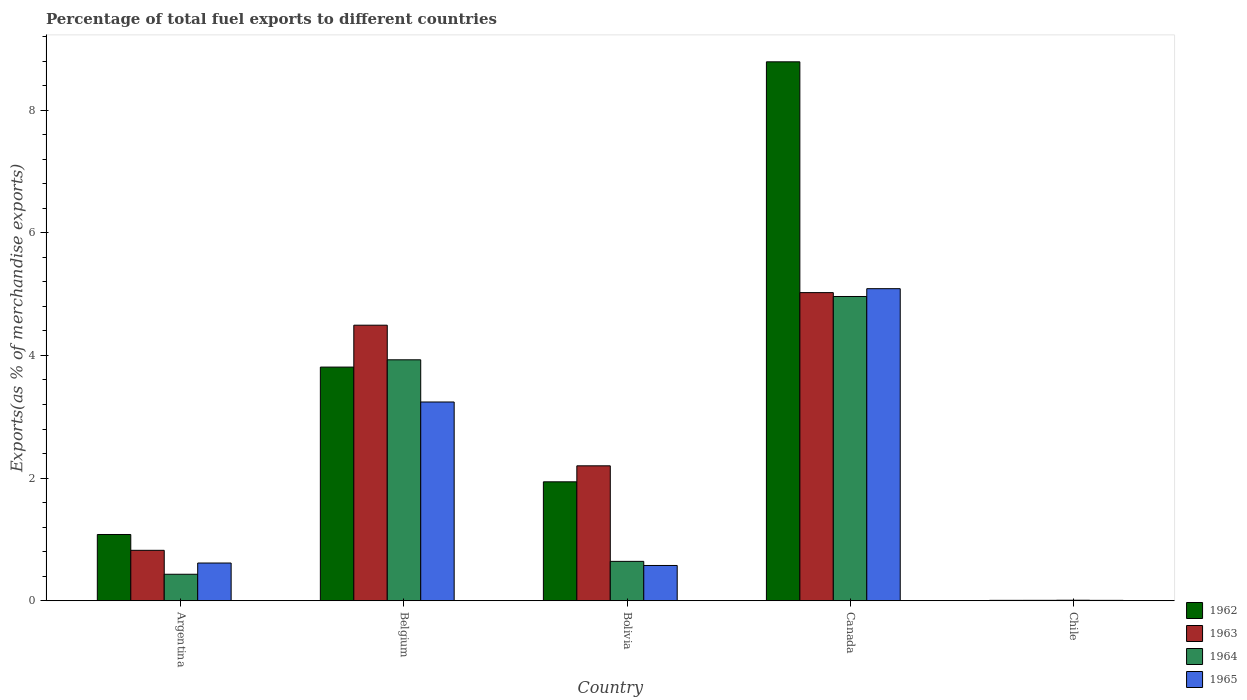How many groups of bars are there?
Provide a short and direct response. 5. Are the number of bars on each tick of the X-axis equal?
Keep it short and to the point. Yes. How many bars are there on the 2nd tick from the left?
Make the answer very short. 4. What is the label of the 2nd group of bars from the left?
Offer a very short reply. Belgium. What is the percentage of exports to different countries in 1965 in Argentina?
Provide a succinct answer. 0.62. Across all countries, what is the maximum percentage of exports to different countries in 1964?
Offer a very short reply. 4.96. Across all countries, what is the minimum percentage of exports to different countries in 1963?
Your response must be concise. 0.01. In which country was the percentage of exports to different countries in 1965 minimum?
Your answer should be very brief. Chile. What is the total percentage of exports to different countries in 1965 in the graph?
Provide a short and direct response. 9.53. What is the difference between the percentage of exports to different countries in 1965 in Bolivia and that in Chile?
Offer a terse response. 0.57. What is the difference between the percentage of exports to different countries in 1964 in Bolivia and the percentage of exports to different countries in 1965 in Chile?
Your answer should be very brief. 0.64. What is the average percentage of exports to different countries in 1964 per country?
Make the answer very short. 1.99. What is the difference between the percentage of exports to different countries of/in 1964 and percentage of exports to different countries of/in 1962 in Chile?
Your answer should be very brief. 0. What is the ratio of the percentage of exports to different countries in 1965 in Argentina to that in Belgium?
Provide a succinct answer. 0.19. Is the difference between the percentage of exports to different countries in 1964 in Belgium and Bolivia greater than the difference between the percentage of exports to different countries in 1962 in Belgium and Bolivia?
Offer a terse response. Yes. What is the difference between the highest and the second highest percentage of exports to different countries in 1965?
Offer a terse response. -2.63. What is the difference between the highest and the lowest percentage of exports to different countries in 1964?
Provide a succinct answer. 4.95. In how many countries, is the percentage of exports to different countries in 1963 greater than the average percentage of exports to different countries in 1963 taken over all countries?
Your response must be concise. 2. What does the 1st bar from the left in Belgium represents?
Provide a succinct answer. 1962. Is it the case that in every country, the sum of the percentage of exports to different countries in 1962 and percentage of exports to different countries in 1963 is greater than the percentage of exports to different countries in 1965?
Offer a terse response. Yes. What is the difference between two consecutive major ticks on the Y-axis?
Keep it short and to the point. 2. Does the graph contain any zero values?
Offer a terse response. No. Does the graph contain grids?
Your response must be concise. No. How are the legend labels stacked?
Offer a terse response. Vertical. What is the title of the graph?
Your answer should be compact. Percentage of total fuel exports to different countries. Does "1966" appear as one of the legend labels in the graph?
Make the answer very short. No. What is the label or title of the Y-axis?
Make the answer very short. Exports(as % of merchandise exports). What is the Exports(as % of merchandise exports) in 1962 in Argentina?
Ensure brevity in your answer.  1.08. What is the Exports(as % of merchandise exports) in 1963 in Argentina?
Your response must be concise. 0.82. What is the Exports(as % of merchandise exports) in 1964 in Argentina?
Provide a succinct answer. 0.43. What is the Exports(as % of merchandise exports) in 1965 in Argentina?
Give a very brief answer. 0.62. What is the Exports(as % of merchandise exports) of 1962 in Belgium?
Ensure brevity in your answer.  3.81. What is the Exports(as % of merchandise exports) of 1963 in Belgium?
Offer a terse response. 4.49. What is the Exports(as % of merchandise exports) in 1964 in Belgium?
Give a very brief answer. 3.93. What is the Exports(as % of merchandise exports) in 1965 in Belgium?
Offer a terse response. 3.24. What is the Exports(as % of merchandise exports) of 1962 in Bolivia?
Keep it short and to the point. 1.94. What is the Exports(as % of merchandise exports) in 1963 in Bolivia?
Ensure brevity in your answer.  2.2. What is the Exports(as % of merchandise exports) in 1964 in Bolivia?
Your response must be concise. 0.64. What is the Exports(as % of merchandise exports) of 1965 in Bolivia?
Ensure brevity in your answer.  0.58. What is the Exports(as % of merchandise exports) of 1962 in Canada?
Keep it short and to the point. 8.79. What is the Exports(as % of merchandise exports) in 1963 in Canada?
Give a very brief answer. 5.02. What is the Exports(as % of merchandise exports) of 1964 in Canada?
Make the answer very short. 4.96. What is the Exports(as % of merchandise exports) of 1965 in Canada?
Offer a very short reply. 5.09. What is the Exports(as % of merchandise exports) in 1962 in Chile?
Keep it short and to the point. 0.01. What is the Exports(as % of merchandise exports) of 1963 in Chile?
Your answer should be compact. 0.01. What is the Exports(as % of merchandise exports) in 1964 in Chile?
Make the answer very short. 0.01. What is the Exports(as % of merchandise exports) of 1965 in Chile?
Keep it short and to the point. 0.01. Across all countries, what is the maximum Exports(as % of merchandise exports) in 1962?
Your answer should be compact. 8.79. Across all countries, what is the maximum Exports(as % of merchandise exports) of 1963?
Your answer should be very brief. 5.02. Across all countries, what is the maximum Exports(as % of merchandise exports) of 1964?
Offer a terse response. 4.96. Across all countries, what is the maximum Exports(as % of merchandise exports) of 1965?
Provide a short and direct response. 5.09. Across all countries, what is the minimum Exports(as % of merchandise exports) in 1962?
Keep it short and to the point. 0.01. Across all countries, what is the minimum Exports(as % of merchandise exports) of 1963?
Offer a terse response. 0.01. Across all countries, what is the minimum Exports(as % of merchandise exports) of 1964?
Your answer should be compact. 0.01. Across all countries, what is the minimum Exports(as % of merchandise exports) of 1965?
Keep it short and to the point. 0.01. What is the total Exports(as % of merchandise exports) in 1962 in the graph?
Your response must be concise. 15.63. What is the total Exports(as % of merchandise exports) in 1963 in the graph?
Provide a short and direct response. 12.55. What is the total Exports(as % of merchandise exports) of 1964 in the graph?
Your answer should be very brief. 9.97. What is the total Exports(as % of merchandise exports) of 1965 in the graph?
Your answer should be compact. 9.53. What is the difference between the Exports(as % of merchandise exports) in 1962 in Argentina and that in Belgium?
Your response must be concise. -2.73. What is the difference between the Exports(as % of merchandise exports) of 1963 in Argentina and that in Belgium?
Your answer should be very brief. -3.67. What is the difference between the Exports(as % of merchandise exports) in 1964 in Argentina and that in Belgium?
Provide a succinct answer. -3.5. What is the difference between the Exports(as % of merchandise exports) in 1965 in Argentina and that in Belgium?
Provide a succinct answer. -2.63. What is the difference between the Exports(as % of merchandise exports) of 1962 in Argentina and that in Bolivia?
Provide a succinct answer. -0.86. What is the difference between the Exports(as % of merchandise exports) of 1963 in Argentina and that in Bolivia?
Provide a succinct answer. -1.38. What is the difference between the Exports(as % of merchandise exports) of 1964 in Argentina and that in Bolivia?
Your answer should be compact. -0.21. What is the difference between the Exports(as % of merchandise exports) of 1965 in Argentina and that in Bolivia?
Your response must be concise. 0.04. What is the difference between the Exports(as % of merchandise exports) of 1962 in Argentina and that in Canada?
Provide a short and direct response. -7.71. What is the difference between the Exports(as % of merchandise exports) in 1963 in Argentina and that in Canada?
Your answer should be compact. -4.2. What is the difference between the Exports(as % of merchandise exports) in 1964 in Argentina and that in Canada?
Your answer should be very brief. -4.53. What is the difference between the Exports(as % of merchandise exports) in 1965 in Argentina and that in Canada?
Offer a very short reply. -4.47. What is the difference between the Exports(as % of merchandise exports) in 1962 in Argentina and that in Chile?
Keep it short and to the point. 1.07. What is the difference between the Exports(as % of merchandise exports) of 1963 in Argentina and that in Chile?
Keep it short and to the point. 0.82. What is the difference between the Exports(as % of merchandise exports) of 1964 in Argentina and that in Chile?
Provide a succinct answer. 0.42. What is the difference between the Exports(as % of merchandise exports) in 1965 in Argentina and that in Chile?
Offer a terse response. 0.61. What is the difference between the Exports(as % of merchandise exports) in 1962 in Belgium and that in Bolivia?
Make the answer very short. 1.87. What is the difference between the Exports(as % of merchandise exports) in 1963 in Belgium and that in Bolivia?
Your answer should be very brief. 2.29. What is the difference between the Exports(as % of merchandise exports) in 1964 in Belgium and that in Bolivia?
Keep it short and to the point. 3.29. What is the difference between the Exports(as % of merchandise exports) in 1965 in Belgium and that in Bolivia?
Make the answer very short. 2.67. What is the difference between the Exports(as % of merchandise exports) in 1962 in Belgium and that in Canada?
Keep it short and to the point. -4.98. What is the difference between the Exports(as % of merchandise exports) in 1963 in Belgium and that in Canada?
Ensure brevity in your answer.  -0.53. What is the difference between the Exports(as % of merchandise exports) in 1964 in Belgium and that in Canada?
Give a very brief answer. -1.03. What is the difference between the Exports(as % of merchandise exports) of 1965 in Belgium and that in Canada?
Ensure brevity in your answer.  -1.85. What is the difference between the Exports(as % of merchandise exports) of 1962 in Belgium and that in Chile?
Give a very brief answer. 3.8. What is the difference between the Exports(as % of merchandise exports) in 1963 in Belgium and that in Chile?
Offer a terse response. 4.49. What is the difference between the Exports(as % of merchandise exports) in 1964 in Belgium and that in Chile?
Your answer should be very brief. 3.92. What is the difference between the Exports(as % of merchandise exports) of 1965 in Belgium and that in Chile?
Your answer should be very brief. 3.23. What is the difference between the Exports(as % of merchandise exports) of 1962 in Bolivia and that in Canada?
Keep it short and to the point. -6.85. What is the difference between the Exports(as % of merchandise exports) in 1963 in Bolivia and that in Canada?
Offer a very short reply. -2.82. What is the difference between the Exports(as % of merchandise exports) of 1964 in Bolivia and that in Canada?
Your answer should be compact. -4.32. What is the difference between the Exports(as % of merchandise exports) in 1965 in Bolivia and that in Canada?
Your answer should be compact. -4.51. What is the difference between the Exports(as % of merchandise exports) in 1962 in Bolivia and that in Chile?
Keep it short and to the point. 1.93. What is the difference between the Exports(as % of merchandise exports) in 1963 in Bolivia and that in Chile?
Ensure brevity in your answer.  2.19. What is the difference between the Exports(as % of merchandise exports) of 1964 in Bolivia and that in Chile?
Give a very brief answer. 0.63. What is the difference between the Exports(as % of merchandise exports) in 1965 in Bolivia and that in Chile?
Your response must be concise. 0.57. What is the difference between the Exports(as % of merchandise exports) of 1962 in Canada and that in Chile?
Your response must be concise. 8.78. What is the difference between the Exports(as % of merchandise exports) in 1963 in Canada and that in Chile?
Provide a short and direct response. 5.02. What is the difference between the Exports(as % of merchandise exports) in 1964 in Canada and that in Chile?
Make the answer very short. 4.95. What is the difference between the Exports(as % of merchandise exports) in 1965 in Canada and that in Chile?
Your answer should be compact. 5.08. What is the difference between the Exports(as % of merchandise exports) in 1962 in Argentina and the Exports(as % of merchandise exports) in 1963 in Belgium?
Keep it short and to the point. -3.41. What is the difference between the Exports(as % of merchandise exports) of 1962 in Argentina and the Exports(as % of merchandise exports) of 1964 in Belgium?
Keep it short and to the point. -2.85. What is the difference between the Exports(as % of merchandise exports) of 1962 in Argentina and the Exports(as % of merchandise exports) of 1965 in Belgium?
Make the answer very short. -2.16. What is the difference between the Exports(as % of merchandise exports) of 1963 in Argentina and the Exports(as % of merchandise exports) of 1964 in Belgium?
Provide a succinct answer. -3.11. What is the difference between the Exports(as % of merchandise exports) of 1963 in Argentina and the Exports(as % of merchandise exports) of 1965 in Belgium?
Your response must be concise. -2.42. What is the difference between the Exports(as % of merchandise exports) of 1964 in Argentina and the Exports(as % of merchandise exports) of 1965 in Belgium?
Give a very brief answer. -2.81. What is the difference between the Exports(as % of merchandise exports) in 1962 in Argentina and the Exports(as % of merchandise exports) in 1963 in Bolivia?
Give a very brief answer. -1.12. What is the difference between the Exports(as % of merchandise exports) in 1962 in Argentina and the Exports(as % of merchandise exports) in 1964 in Bolivia?
Give a very brief answer. 0.44. What is the difference between the Exports(as % of merchandise exports) in 1962 in Argentina and the Exports(as % of merchandise exports) in 1965 in Bolivia?
Keep it short and to the point. 0.51. What is the difference between the Exports(as % of merchandise exports) in 1963 in Argentina and the Exports(as % of merchandise exports) in 1964 in Bolivia?
Provide a succinct answer. 0.18. What is the difference between the Exports(as % of merchandise exports) in 1963 in Argentina and the Exports(as % of merchandise exports) in 1965 in Bolivia?
Ensure brevity in your answer.  0.25. What is the difference between the Exports(as % of merchandise exports) in 1964 in Argentina and the Exports(as % of merchandise exports) in 1965 in Bolivia?
Give a very brief answer. -0.14. What is the difference between the Exports(as % of merchandise exports) of 1962 in Argentina and the Exports(as % of merchandise exports) of 1963 in Canada?
Provide a short and direct response. -3.94. What is the difference between the Exports(as % of merchandise exports) of 1962 in Argentina and the Exports(as % of merchandise exports) of 1964 in Canada?
Ensure brevity in your answer.  -3.88. What is the difference between the Exports(as % of merchandise exports) of 1962 in Argentina and the Exports(as % of merchandise exports) of 1965 in Canada?
Keep it short and to the point. -4.01. What is the difference between the Exports(as % of merchandise exports) in 1963 in Argentina and the Exports(as % of merchandise exports) in 1964 in Canada?
Ensure brevity in your answer.  -4.14. What is the difference between the Exports(as % of merchandise exports) in 1963 in Argentina and the Exports(as % of merchandise exports) in 1965 in Canada?
Your response must be concise. -4.27. What is the difference between the Exports(as % of merchandise exports) in 1964 in Argentina and the Exports(as % of merchandise exports) in 1965 in Canada?
Ensure brevity in your answer.  -4.66. What is the difference between the Exports(as % of merchandise exports) in 1962 in Argentina and the Exports(as % of merchandise exports) in 1963 in Chile?
Your answer should be compact. 1.07. What is the difference between the Exports(as % of merchandise exports) of 1962 in Argentina and the Exports(as % of merchandise exports) of 1964 in Chile?
Ensure brevity in your answer.  1.07. What is the difference between the Exports(as % of merchandise exports) of 1962 in Argentina and the Exports(as % of merchandise exports) of 1965 in Chile?
Offer a terse response. 1.07. What is the difference between the Exports(as % of merchandise exports) in 1963 in Argentina and the Exports(as % of merchandise exports) in 1964 in Chile?
Ensure brevity in your answer.  0.81. What is the difference between the Exports(as % of merchandise exports) in 1963 in Argentina and the Exports(as % of merchandise exports) in 1965 in Chile?
Your answer should be compact. 0.82. What is the difference between the Exports(as % of merchandise exports) of 1964 in Argentina and the Exports(as % of merchandise exports) of 1965 in Chile?
Offer a terse response. 0.43. What is the difference between the Exports(as % of merchandise exports) of 1962 in Belgium and the Exports(as % of merchandise exports) of 1963 in Bolivia?
Keep it short and to the point. 1.61. What is the difference between the Exports(as % of merchandise exports) in 1962 in Belgium and the Exports(as % of merchandise exports) in 1964 in Bolivia?
Provide a succinct answer. 3.17. What is the difference between the Exports(as % of merchandise exports) in 1962 in Belgium and the Exports(as % of merchandise exports) in 1965 in Bolivia?
Your answer should be very brief. 3.23. What is the difference between the Exports(as % of merchandise exports) of 1963 in Belgium and the Exports(as % of merchandise exports) of 1964 in Bolivia?
Provide a succinct answer. 3.85. What is the difference between the Exports(as % of merchandise exports) in 1963 in Belgium and the Exports(as % of merchandise exports) in 1965 in Bolivia?
Give a very brief answer. 3.92. What is the difference between the Exports(as % of merchandise exports) of 1964 in Belgium and the Exports(as % of merchandise exports) of 1965 in Bolivia?
Provide a short and direct response. 3.35. What is the difference between the Exports(as % of merchandise exports) of 1962 in Belgium and the Exports(as % of merchandise exports) of 1963 in Canada?
Provide a succinct answer. -1.21. What is the difference between the Exports(as % of merchandise exports) in 1962 in Belgium and the Exports(as % of merchandise exports) in 1964 in Canada?
Provide a short and direct response. -1.15. What is the difference between the Exports(as % of merchandise exports) in 1962 in Belgium and the Exports(as % of merchandise exports) in 1965 in Canada?
Ensure brevity in your answer.  -1.28. What is the difference between the Exports(as % of merchandise exports) in 1963 in Belgium and the Exports(as % of merchandise exports) in 1964 in Canada?
Offer a terse response. -0.47. What is the difference between the Exports(as % of merchandise exports) in 1963 in Belgium and the Exports(as % of merchandise exports) in 1965 in Canada?
Give a very brief answer. -0.6. What is the difference between the Exports(as % of merchandise exports) of 1964 in Belgium and the Exports(as % of merchandise exports) of 1965 in Canada?
Ensure brevity in your answer.  -1.16. What is the difference between the Exports(as % of merchandise exports) in 1962 in Belgium and the Exports(as % of merchandise exports) in 1963 in Chile?
Offer a terse response. 3.8. What is the difference between the Exports(as % of merchandise exports) of 1962 in Belgium and the Exports(as % of merchandise exports) of 1964 in Chile?
Provide a short and direct response. 3.8. What is the difference between the Exports(as % of merchandise exports) in 1962 in Belgium and the Exports(as % of merchandise exports) in 1965 in Chile?
Offer a very short reply. 3.8. What is the difference between the Exports(as % of merchandise exports) in 1963 in Belgium and the Exports(as % of merchandise exports) in 1964 in Chile?
Your answer should be very brief. 4.48. What is the difference between the Exports(as % of merchandise exports) in 1963 in Belgium and the Exports(as % of merchandise exports) in 1965 in Chile?
Provide a succinct answer. 4.49. What is the difference between the Exports(as % of merchandise exports) in 1964 in Belgium and the Exports(as % of merchandise exports) in 1965 in Chile?
Ensure brevity in your answer.  3.92. What is the difference between the Exports(as % of merchandise exports) in 1962 in Bolivia and the Exports(as % of merchandise exports) in 1963 in Canada?
Your answer should be very brief. -3.08. What is the difference between the Exports(as % of merchandise exports) in 1962 in Bolivia and the Exports(as % of merchandise exports) in 1964 in Canada?
Your answer should be very brief. -3.02. What is the difference between the Exports(as % of merchandise exports) of 1962 in Bolivia and the Exports(as % of merchandise exports) of 1965 in Canada?
Your answer should be compact. -3.15. What is the difference between the Exports(as % of merchandise exports) of 1963 in Bolivia and the Exports(as % of merchandise exports) of 1964 in Canada?
Provide a short and direct response. -2.76. What is the difference between the Exports(as % of merchandise exports) in 1963 in Bolivia and the Exports(as % of merchandise exports) in 1965 in Canada?
Make the answer very short. -2.89. What is the difference between the Exports(as % of merchandise exports) of 1964 in Bolivia and the Exports(as % of merchandise exports) of 1965 in Canada?
Your answer should be compact. -4.45. What is the difference between the Exports(as % of merchandise exports) of 1962 in Bolivia and the Exports(as % of merchandise exports) of 1963 in Chile?
Your answer should be very brief. 1.93. What is the difference between the Exports(as % of merchandise exports) in 1962 in Bolivia and the Exports(as % of merchandise exports) in 1964 in Chile?
Offer a terse response. 1.93. What is the difference between the Exports(as % of merchandise exports) of 1962 in Bolivia and the Exports(as % of merchandise exports) of 1965 in Chile?
Provide a succinct answer. 1.93. What is the difference between the Exports(as % of merchandise exports) in 1963 in Bolivia and the Exports(as % of merchandise exports) in 1964 in Chile?
Your answer should be very brief. 2.19. What is the difference between the Exports(as % of merchandise exports) in 1963 in Bolivia and the Exports(as % of merchandise exports) in 1965 in Chile?
Provide a succinct answer. 2.19. What is the difference between the Exports(as % of merchandise exports) of 1964 in Bolivia and the Exports(as % of merchandise exports) of 1965 in Chile?
Provide a succinct answer. 0.64. What is the difference between the Exports(as % of merchandise exports) in 1962 in Canada and the Exports(as % of merchandise exports) in 1963 in Chile?
Make the answer very short. 8.78. What is the difference between the Exports(as % of merchandise exports) of 1962 in Canada and the Exports(as % of merchandise exports) of 1964 in Chile?
Make the answer very short. 8.78. What is the difference between the Exports(as % of merchandise exports) of 1962 in Canada and the Exports(as % of merchandise exports) of 1965 in Chile?
Your response must be concise. 8.78. What is the difference between the Exports(as % of merchandise exports) of 1963 in Canada and the Exports(as % of merchandise exports) of 1964 in Chile?
Offer a very short reply. 5.02. What is the difference between the Exports(as % of merchandise exports) of 1963 in Canada and the Exports(as % of merchandise exports) of 1965 in Chile?
Offer a very short reply. 5.02. What is the difference between the Exports(as % of merchandise exports) of 1964 in Canada and the Exports(as % of merchandise exports) of 1965 in Chile?
Your answer should be very brief. 4.95. What is the average Exports(as % of merchandise exports) of 1962 per country?
Make the answer very short. 3.13. What is the average Exports(as % of merchandise exports) in 1963 per country?
Make the answer very short. 2.51. What is the average Exports(as % of merchandise exports) in 1964 per country?
Offer a terse response. 1.99. What is the average Exports(as % of merchandise exports) of 1965 per country?
Provide a succinct answer. 1.91. What is the difference between the Exports(as % of merchandise exports) in 1962 and Exports(as % of merchandise exports) in 1963 in Argentina?
Keep it short and to the point. 0.26. What is the difference between the Exports(as % of merchandise exports) in 1962 and Exports(as % of merchandise exports) in 1964 in Argentina?
Your response must be concise. 0.65. What is the difference between the Exports(as % of merchandise exports) of 1962 and Exports(as % of merchandise exports) of 1965 in Argentina?
Offer a very short reply. 0.47. What is the difference between the Exports(as % of merchandise exports) of 1963 and Exports(as % of merchandise exports) of 1964 in Argentina?
Offer a very short reply. 0.39. What is the difference between the Exports(as % of merchandise exports) in 1963 and Exports(as % of merchandise exports) in 1965 in Argentina?
Provide a succinct answer. 0.21. What is the difference between the Exports(as % of merchandise exports) in 1964 and Exports(as % of merchandise exports) in 1965 in Argentina?
Offer a terse response. -0.18. What is the difference between the Exports(as % of merchandise exports) of 1962 and Exports(as % of merchandise exports) of 1963 in Belgium?
Your answer should be very brief. -0.68. What is the difference between the Exports(as % of merchandise exports) in 1962 and Exports(as % of merchandise exports) in 1964 in Belgium?
Keep it short and to the point. -0.12. What is the difference between the Exports(as % of merchandise exports) of 1962 and Exports(as % of merchandise exports) of 1965 in Belgium?
Your answer should be very brief. 0.57. What is the difference between the Exports(as % of merchandise exports) of 1963 and Exports(as % of merchandise exports) of 1964 in Belgium?
Your response must be concise. 0.56. What is the difference between the Exports(as % of merchandise exports) in 1963 and Exports(as % of merchandise exports) in 1965 in Belgium?
Make the answer very short. 1.25. What is the difference between the Exports(as % of merchandise exports) in 1964 and Exports(as % of merchandise exports) in 1965 in Belgium?
Provide a succinct answer. 0.69. What is the difference between the Exports(as % of merchandise exports) in 1962 and Exports(as % of merchandise exports) in 1963 in Bolivia?
Offer a very short reply. -0.26. What is the difference between the Exports(as % of merchandise exports) of 1962 and Exports(as % of merchandise exports) of 1964 in Bolivia?
Provide a short and direct response. 1.3. What is the difference between the Exports(as % of merchandise exports) in 1962 and Exports(as % of merchandise exports) in 1965 in Bolivia?
Ensure brevity in your answer.  1.36. What is the difference between the Exports(as % of merchandise exports) of 1963 and Exports(as % of merchandise exports) of 1964 in Bolivia?
Your response must be concise. 1.56. What is the difference between the Exports(as % of merchandise exports) of 1963 and Exports(as % of merchandise exports) of 1965 in Bolivia?
Ensure brevity in your answer.  1.62. What is the difference between the Exports(as % of merchandise exports) in 1964 and Exports(as % of merchandise exports) in 1965 in Bolivia?
Give a very brief answer. 0.07. What is the difference between the Exports(as % of merchandise exports) of 1962 and Exports(as % of merchandise exports) of 1963 in Canada?
Your answer should be compact. 3.76. What is the difference between the Exports(as % of merchandise exports) in 1962 and Exports(as % of merchandise exports) in 1964 in Canada?
Offer a terse response. 3.83. What is the difference between the Exports(as % of merchandise exports) in 1962 and Exports(as % of merchandise exports) in 1965 in Canada?
Your answer should be very brief. 3.7. What is the difference between the Exports(as % of merchandise exports) in 1963 and Exports(as % of merchandise exports) in 1964 in Canada?
Your answer should be compact. 0.06. What is the difference between the Exports(as % of merchandise exports) in 1963 and Exports(as % of merchandise exports) in 1965 in Canada?
Your response must be concise. -0.06. What is the difference between the Exports(as % of merchandise exports) in 1964 and Exports(as % of merchandise exports) in 1965 in Canada?
Ensure brevity in your answer.  -0.13. What is the difference between the Exports(as % of merchandise exports) of 1962 and Exports(as % of merchandise exports) of 1963 in Chile?
Offer a very short reply. -0. What is the difference between the Exports(as % of merchandise exports) of 1962 and Exports(as % of merchandise exports) of 1964 in Chile?
Keep it short and to the point. -0. What is the difference between the Exports(as % of merchandise exports) of 1963 and Exports(as % of merchandise exports) of 1964 in Chile?
Provide a succinct answer. -0. What is the difference between the Exports(as % of merchandise exports) of 1964 and Exports(as % of merchandise exports) of 1965 in Chile?
Your answer should be compact. 0. What is the ratio of the Exports(as % of merchandise exports) in 1962 in Argentina to that in Belgium?
Your answer should be compact. 0.28. What is the ratio of the Exports(as % of merchandise exports) in 1963 in Argentina to that in Belgium?
Offer a terse response. 0.18. What is the ratio of the Exports(as % of merchandise exports) in 1964 in Argentina to that in Belgium?
Make the answer very short. 0.11. What is the ratio of the Exports(as % of merchandise exports) in 1965 in Argentina to that in Belgium?
Provide a short and direct response. 0.19. What is the ratio of the Exports(as % of merchandise exports) of 1962 in Argentina to that in Bolivia?
Your answer should be very brief. 0.56. What is the ratio of the Exports(as % of merchandise exports) of 1963 in Argentina to that in Bolivia?
Your answer should be very brief. 0.37. What is the ratio of the Exports(as % of merchandise exports) in 1964 in Argentina to that in Bolivia?
Keep it short and to the point. 0.67. What is the ratio of the Exports(as % of merchandise exports) of 1965 in Argentina to that in Bolivia?
Your response must be concise. 1.07. What is the ratio of the Exports(as % of merchandise exports) of 1962 in Argentina to that in Canada?
Make the answer very short. 0.12. What is the ratio of the Exports(as % of merchandise exports) of 1963 in Argentina to that in Canada?
Your answer should be very brief. 0.16. What is the ratio of the Exports(as % of merchandise exports) in 1964 in Argentina to that in Canada?
Offer a terse response. 0.09. What is the ratio of the Exports(as % of merchandise exports) in 1965 in Argentina to that in Canada?
Provide a succinct answer. 0.12. What is the ratio of the Exports(as % of merchandise exports) of 1962 in Argentina to that in Chile?
Keep it short and to the point. 154.28. What is the ratio of the Exports(as % of merchandise exports) of 1963 in Argentina to that in Chile?
Make the answer very short. 116.11. What is the ratio of the Exports(as % of merchandise exports) of 1964 in Argentina to that in Chile?
Make the answer very short. 48.39. What is the ratio of the Exports(as % of merchandise exports) of 1965 in Argentina to that in Chile?
Your answer should be compact. 91.07. What is the ratio of the Exports(as % of merchandise exports) in 1962 in Belgium to that in Bolivia?
Ensure brevity in your answer.  1.96. What is the ratio of the Exports(as % of merchandise exports) in 1963 in Belgium to that in Bolivia?
Provide a short and direct response. 2.04. What is the ratio of the Exports(as % of merchandise exports) of 1964 in Belgium to that in Bolivia?
Give a very brief answer. 6.12. What is the ratio of the Exports(as % of merchandise exports) of 1965 in Belgium to that in Bolivia?
Offer a very short reply. 5.63. What is the ratio of the Exports(as % of merchandise exports) of 1962 in Belgium to that in Canada?
Ensure brevity in your answer.  0.43. What is the ratio of the Exports(as % of merchandise exports) of 1963 in Belgium to that in Canada?
Ensure brevity in your answer.  0.89. What is the ratio of the Exports(as % of merchandise exports) in 1964 in Belgium to that in Canada?
Keep it short and to the point. 0.79. What is the ratio of the Exports(as % of merchandise exports) in 1965 in Belgium to that in Canada?
Your response must be concise. 0.64. What is the ratio of the Exports(as % of merchandise exports) in 1962 in Belgium to that in Chile?
Your answer should be compact. 543.89. What is the ratio of the Exports(as % of merchandise exports) of 1963 in Belgium to that in Chile?
Ensure brevity in your answer.  634.23. What is the ratio of the Exports(as % of merchandise exports) in 1964 in Belgium to that in Chile?
Your answer should be very brief. 439.88. What is the ratio of the Exports(as % of merchandise exports) of 1965 in Belgium to that in Chile?
Provide a short and direct response. 479.5. What is the ratio of the Exports(as % of merchandise exports) in 1962 in Bolivia to that in Canada?
Offer a terse response. 0.22. What is the ratio of the Exports(as % of merchandise exports) of 1963 in Bolivia to that in Canada?
Your response must be concise. 0.44. What is the ratio of the Exports(as % of merchandise exports) in 1964 in Bolivia to that in Canada?
Offer a terse response. 0.13. What is the ratio of the Exports(as % of merchandise exports) in 1965 in Bolivia to that in Canada?
Your answer should be compact. 0.11. What is the ratio of the Exports(as % of merchandise exports) of 1962 in Bolivia to that in Chile?
Provide a short and direct response. 276.87. What is the ratio of the Exports(as % of merchandise exports) in 1963 in Bolivia to that in Chile?
Provide a succinct answer. 310.59. What is the ratio of the Exports(as % of merchandise exports) of 1964 in Bolivia to that in Chile?
Provide a short and direct response. 71.92. What is the ratio of the Exports(as % of merchandise exports) in 1965 in Bolivia to that in Chile?
Your answer should be very brief. 85.13. What is the ratio of the Exports(as % of merchandise exports) in 1962 in Canada to that in Chile?
Ensure brevity in your answer.  1254.38. What is the ratio of the Exports(as % of merchandise exports) of 1963 in Canada to that in Chile?
Ensure brevity in your answer.  709.22. What is the ratio of the Exports(as % of merchandise exports) in 1964 in Canada to that in Chile?
Provide a succinct answer. 555.45. What is the ratio of the Exports(as % of merchandise exports) of 1965 in Canada to that in Chile?
Your answer should be compact. 752.83. What is the difference between the highest and the second highest Exports(as % of merchandise exports) in 1962?
Your answer should be very brief. 4.98. What is the difference between the highest and the second highest Exports(as % of merchandise exports) of 1963?
Keep it short and to the point. 0.53. What is the difference between the highest and the second highest Exports(as % of merchandise exports) of 1964?
Give a very brief answer. 1.03. What is the difference between the highest and the second highest Exports(as % of merchandise exports) of 1965?
Your answer should be very brief. 1.85. What is the difference between the highest and the lowest Exports(as % of merchandise exports) in 1962?
Make the answer very short. 8.78. What is the difference between the highest and the lowest Exports(as % of merchandise exports) in 1963?
Your response must be concise. 5.02. What is the difference between the highest and the lowest Exports(as % of merchandise exports) in 1964?
Your answer should be compact. 4.95. What is the difference between the highest and the lowest Exports(as % of merchandise exports) of 1965?
Offer a terse response. 5.08. 